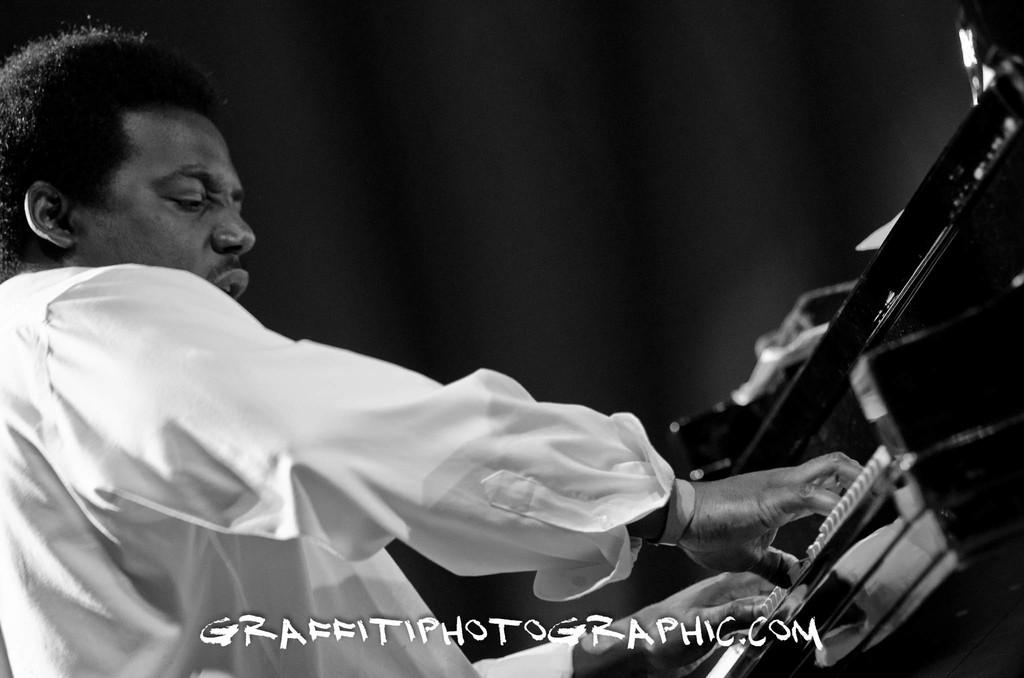What is the main subject of the image? There is a person playing a musical instrument in the image. What can be found at the bottom of the image? There is text at the bottom of the image. How would you describe the overall lighting in the image? The background of the image is dark. How many fish can be seen in the person's hair in the image? There are no fish present in the image, nor are there any fish in the person's hair. 